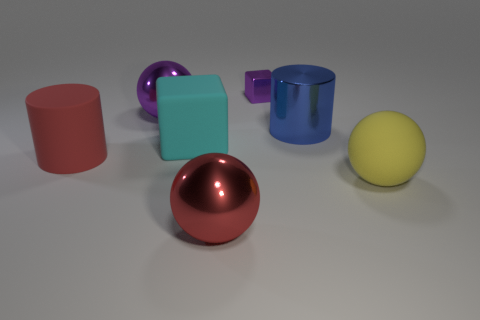Subtract all metallic balls. How many balls are left? 1 Add 1 tiny matte things. How many objects exist? 8 Subtract all cyan blocks. How many blocks are left? 1 Subtract all cubes. How many objects are left? 5 Subtract all big matte blocks. Subtract all cyan blocks. How many objects are left? 5 Add 7 matte spheres. How many matte spheres are left? 8 Add 5 green spheres. How many green spheres exist? 5 Subtract 0 blue blocks. How many objects are left? 7 Subtract 1 balls. How many balls are left? 2 Subtract all red cylinders. Subtract all purple cubes. How many cylinders are left? 1 